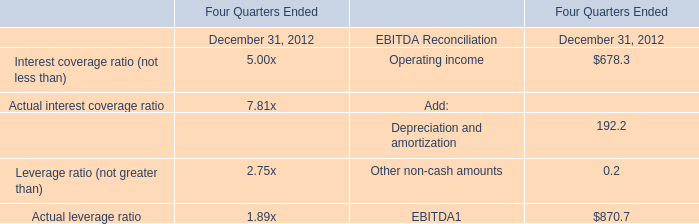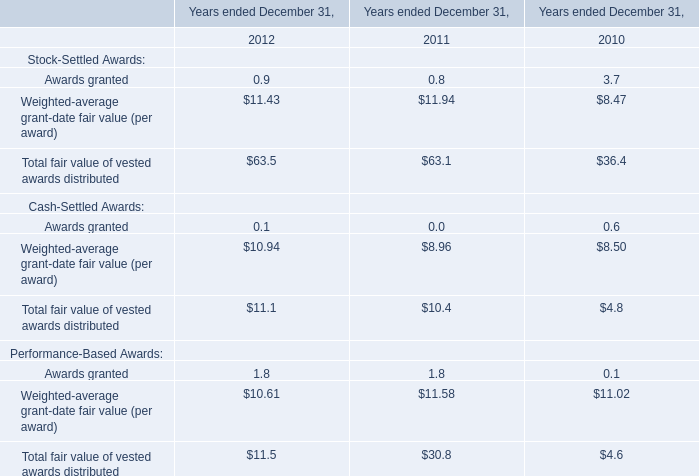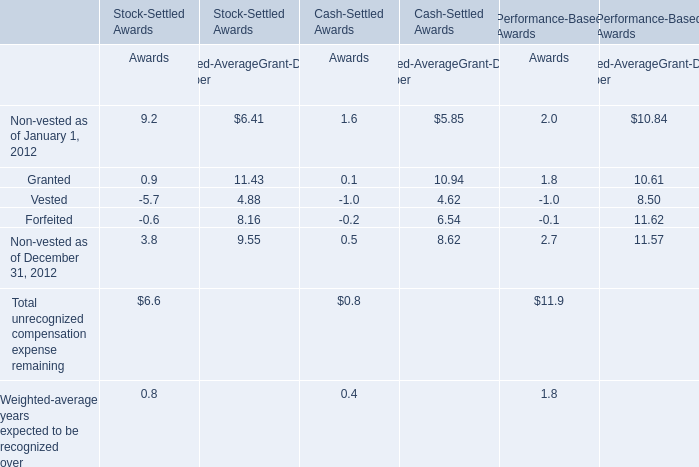What was the total amount of the Weighted-average grant-date fair value (per award) in the years where Total fair value of vested awards distributed greater than 60? 
Computations: (10.94 + 8.96)
Answer: 19.9. 